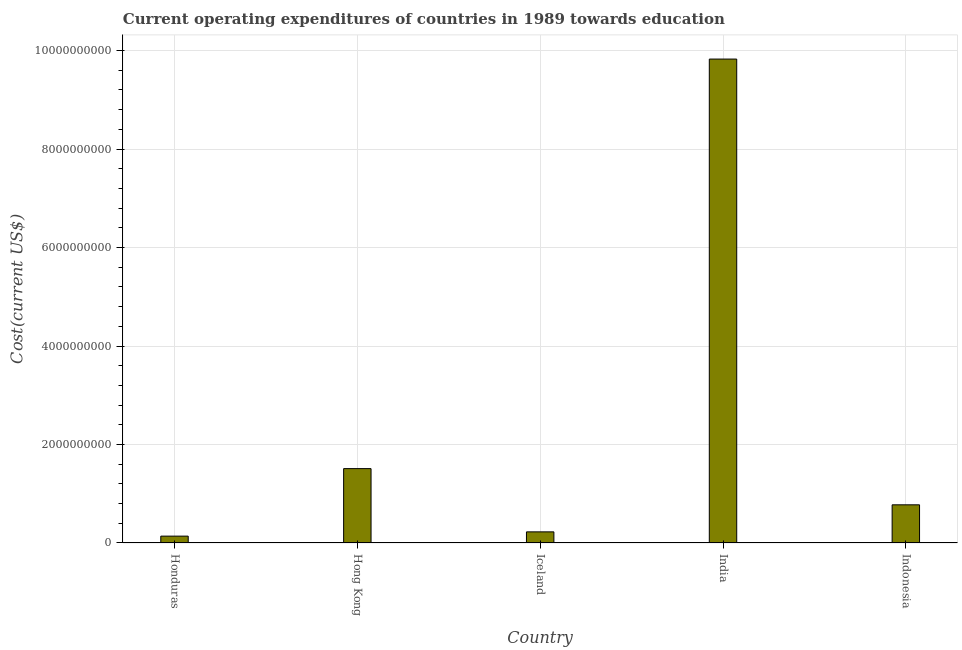What is the title of the graph?
Offer a very short reply. Current operating expenditures of countries in 1989 towards education. What is the label or title of the Y-axis?
Your answer should be compact. Cost(current US$). What is the education expenditure in Iceland?
Your answer should be very brief. 2.26e+08. Across all countries, what is the maximum education expenditure?
Keep it short and to the point. 9.83e+09. Across all countries, what is the minimum education expenditure?
Your answer should be compact. 1.39e+08. In which country was the education expenditure maximum?
Your answer should be compact. India. In which country was the education expenditure minimum?
Your answer should be very brief. Honduras. What is the sum of the education expenditure?
Your answer should be very brief. 1.25e+1. What is the difference between the education expenditure in Hong Kong and Iceland?
Make the answer very short. 1.28e+09. What is the average education expenditure per country?
Your answer should be compact. 2.50e+09. What is the median education expenditure?
Provide a short and direct response. 7.75e+08. What is the ratio of the education expenditure in Honduras to that in Iceland?
Make the answer very short. 0.62. Is the education expenditure in Hong Kong less than that in India?
Give a very brief answer. Yes. Is the difference between the education expenditure in Honduras and Indonesia greater than the difference between any two countries?
Your answer should be compact. No. What is the difference between the highest and the second highest education expenditure?
Offer a very short reply. 8.32e+09. Is the sum of the education expenditure in Iceland and Indonesia greater than the maximum education expenditure across all countries?
Ensure brevity in your answer.  No. What is the difference between the highest and the lowest education expenditure?
Make the answer very short. 9.69e+09. In how many countries, is the education expenditure greater than the average education expenditure taken over all countries?
Make the answer very short. 1. How many bars are there?
Your answer should be very brief. 5. How many countries are there in the graph?
Keep it short and to the point. 5. Are the values on the major ticks of Y-axis written in scientific E-notation?
Give a very brief answer. No. What is the Cost(current US$) in Honduras?
Ensure brevity in your answer.  1.39e+08. What is the Cost(current US$) in Hong Kong?
Give a very brief answer. 1.51e+09. What is the Cost(current US$) in Iceland?
Provide a short and direct response. 2.26e+08. What is the Cost(current US$) in India?
Ensure brevity in your answer.  9.83e+09. What is the Cost(current US$) of Indonesia?
Make the answer very short. 7.75e+08. What is the difference between the Cost(current US$) in Honduras and Hong Kong?
Offer a terse response. -1.37e+09. What is the difference between the Cost(current US$) in Honduras and Iceland?
Keep it short and to the point. -8.67e+07. What is the difference between the Cost(current US$) in Honduras and India?
Your response must be concise. -9.69e+09. What is the difference between the Cost(current US$) in Honduras and Indonesia?
Your answer should be very brief. -6.36e+08. What is the difference between the Cost(current US$) in Hong Kong and Iceland?
Give a very brief answer. 1.28e+09. What is the difference between the Cost(current US$) in Hong Kong and India?
Offer a terse response. -8.32e+09. What is the difference between the Cost(current US$) in Hong Kong and Indonesia?
Your answer should be compact. 7.35e+08. What is the difference between the Cost(current US$) in Iceland and India?
Keep it short and to the point. -9.60e+09. What is the difference between the Cost(current US$) in Iceland and Indonesia?
Ensure brevity in your answer.  -5.49e+08. What is the difference between the Cost(current US$) in India and Indonesia?
Keep it short and to the point. 9.05e+09. What is the ratio of the Cost(current US$) in Honduras to that in Hong Kong?
Ensure brevity in your answer.  0.09. What is the ratio of the Cost(current US$) in Honduras to that in Iceland?
Your answer should be very brief. 0.62. What is the ratio of the Cost(current US$) in Honduras to that in India?
Your answer should be compact. 0.01. What is the ratio of the Cost(current US$) in Honduras to that in Indonesia?
Provide a succinct answer. 0.18. What is the ratio of the Cost(current US$) in Hong Kong to that in Iceland?
Offer a very short reply. 6.68. What is the ratio of the Cost(current US$) in Hong Kong to that in India?
Provide a short and direct response. 0.15. What is the ratio of the Cost(current US$) in Hong Kong to that in Indonesia?
Provide a succinct answer. 1.95. What is the ratio of the Cost(current US$) in Iceland to that in India?
Give a very brief answer. 0.02. What is the ratio of the Cost(current US$) in Iceland to that in Indonesia?
Offer a very short reply. 0.29. What is the ratio of the Cost(current US$) in India to that in Indonesia?
Give a very brief answer. 12.68. 